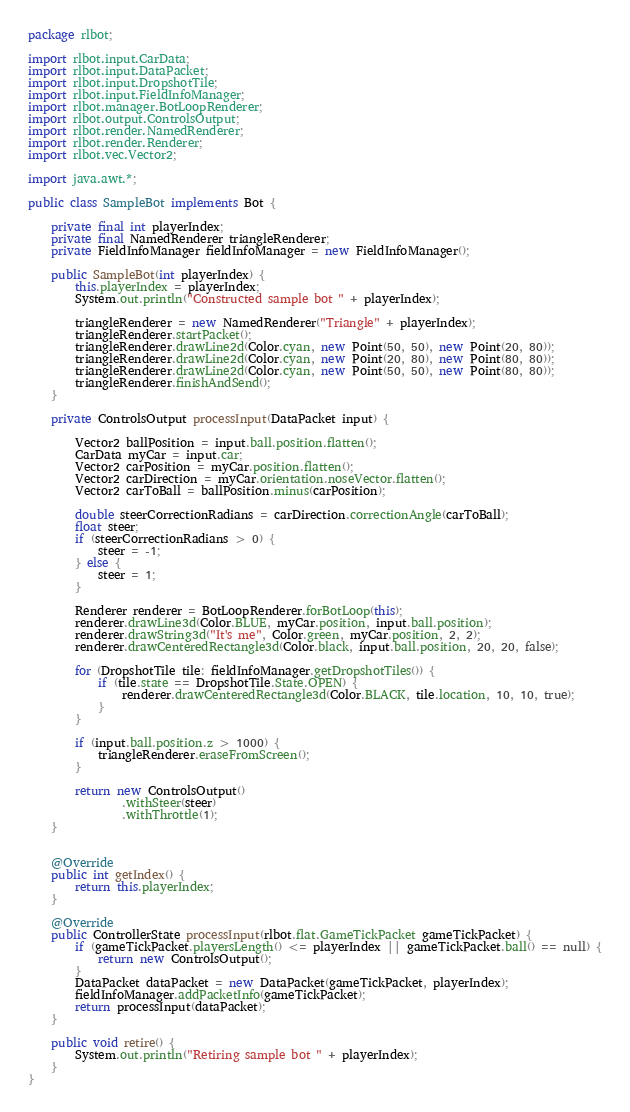Convert code to text. <code><loc_0><loc_0><loc_500><loc_500><_Java_>package rlbot;

import rlbot.input.CarData;
import rlbot.input.DataPacket;
import rlbot.input.DropshotTile;
import rlbot.input.FieldInfoManager;
import rlbot.manager.BotLoopRenderer;
import rlbot.output.ControlsOutput;
import rlbot.render.NamedRenderer;
import rlbot.render.Renderer;
import rlbot.vec.Vector2;

import java.awt.*;

public class SampleBot implements Bot {

    private final int playerIndex;
    private final NamedRenderer triangleRenderer;
    private FieldInfoManager fieldInfoManager = new FieldInfoManager();

    public SampleBot(int playerIndex) {
        this.playerIndex = playerIndex;
        System.out.println("Constructed sample bot " + playerIndex);

        triangleRenderer = new NamedRenderer("Triangle" + playerIndex);
        triangleRenderer.startPacket();
        triangleRenderer.drawLine2d(Color.cyan, new Point(50, 50), new Point(20, 80));
        triangleRenderer.drawLine2d(Color.cyan, new Point(20, 80), new Point(80, 80));
        triangleRenderer.drawLine2d(Color.cyan, new Point(50, 50), new Point(80, 80));
        triangleRenderer.finishAndSend();
    }

    private ControlsOutput processInput(DataPacket input) {

        Vector2 ballPosition = input.ball.position.flatten();
        CarData myCar = input.car;
        Vector2 carPosition = myCar.position.flatten();
        Vector2 carDirection = myCar.orientation.noseVector.flatten();
        Vector2 carToBall = ballPosition.minus(carPosition);

        double steerCorrectionRadians = carDirection.correctionAngle(carToBall);
        float steer;
        if (steerCorrectionRadians > 0) {
            steer = -1;
        } else {
            steer = 1;
        }

        Renderer renderer = BotLoopRenderer.forBotLoop(this);
        renderer.drawLine3d(Color.BLUE, myCar.position, input.ball.position);
        renderer.drawString3d("It's me", Color.green, myCar.position, 2, 2);
        renderer.drawCenteredRectangle3d(Color.black, input.ball.position, 20, 20, false);

        for (DropshotTile tile: fieldInfoManager.getDropshotTiles()) {
            if (tile.state == DropshotTile.State.OPEN) {
                renderer.drawCenteredRectangle3d(Color.BLACK, tile.location, 10, 10, true);
            }
        }

        if (input.ball.position.z > 1000) {
            triangleRenderer.eraseFromScreen();
        }

        return new ControlsOutput()
                .withSteer(steer)
                .withThrottle(1);
    }


    @Override
    public int getIndex() {
        return this.playerIndex;
    }

    @Override
    public ControllerState processInput(rlbot.flat.GameTickPacket gameTickPacket) {
        if (gameTickPacket.playersLength() <= playerIndex || gameTickPacket.ball() == null) {
            return new ControlsOutput();
        }
        DataPacket dataPacket = new DataPacket(gameTickPacket, playerIndex);
        fieldInfoManager.addPacketInfo(gameTickPacket);
        return processInput(dataPacket);
    }

    public void retire() {
        System.out.println("Retiring sample bot " + playerIndex);
    }
}
</code> 